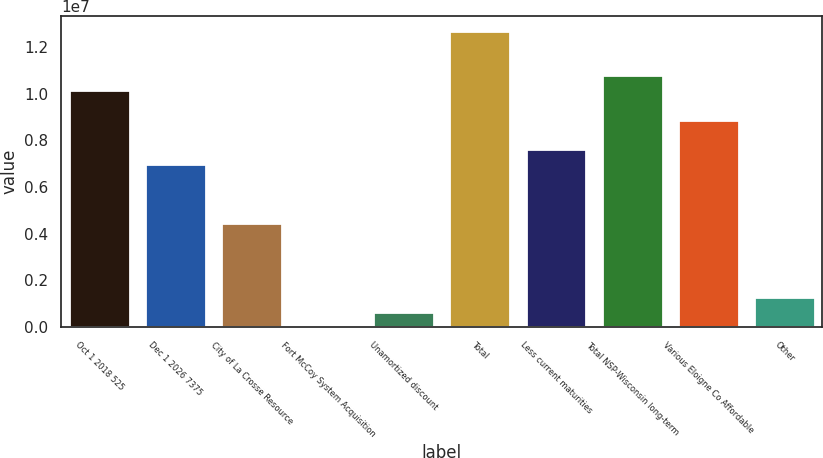Convert chart. <chart><loc_0><loc_0><loc_500><loc_500><bar_chart><fcel>Oct 1 2018 525<fcel>Dec 1 2026 7375<fcel>City of La Crosse Resource<fcel>Fort McCoy System Acquisition<fcel>Unamortized discount<fcel>Total<fcel>Less current maturities<fcel>Total NSP-Wisconsin long-term<fcel>Various Eloigne Co Affordable<fcel>Other<nl><fcel>1.0147e+07<fcel>6.9763e+06<fcel>4.43974e+06<fcel>760<fcel>634900<fcel>1.26836e+07<fcel>7.61044e+06<fcel>1.07811e+07<fcel>8.87872e+06<fcel>1.26904e+06<nl></chart> 